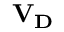Convert formula to latex. <formula><loc_0><loc_0><loc_500><loc_500>V _ { D }</formula> 